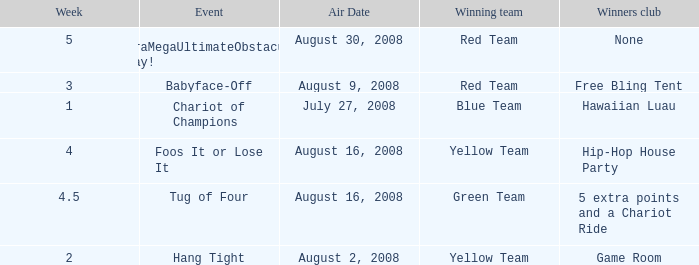Which Winners club has a Week of 4.5? 5 extra points and a Chariot Ride. 